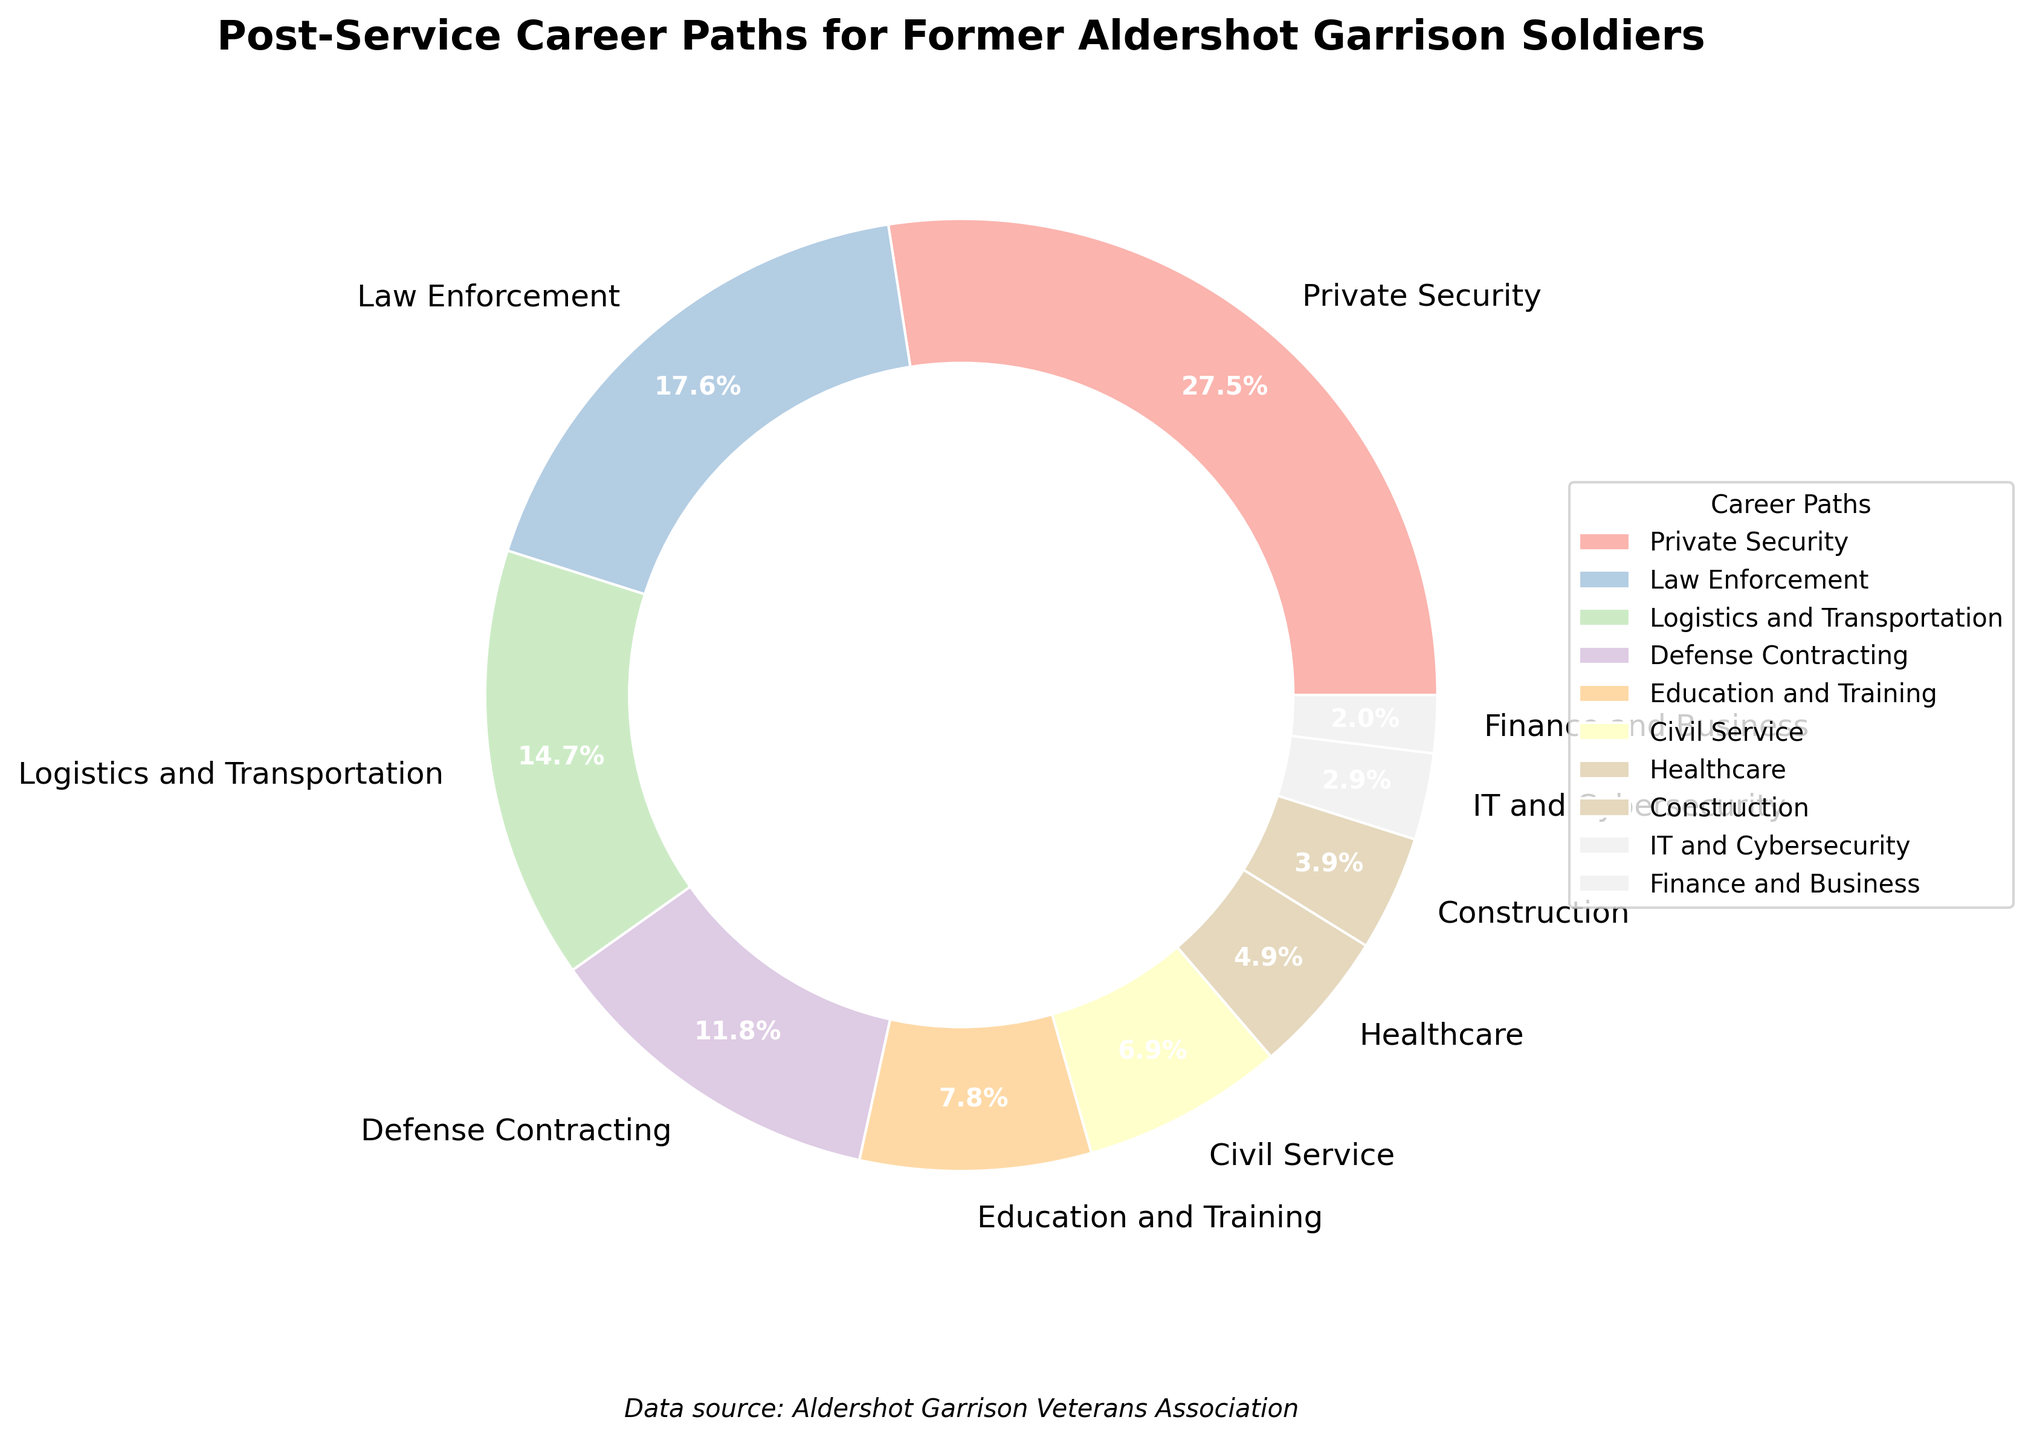What percentage of former Aldershot Garrison soldiers work in Finance and Business? The pie chart shows a sector labeled "Finance and Business" with the percentage clearly indicated.
Answer: 2% What two career paths combined make up exactly 20% of the post-service careers? By adding the percentages of different career paths, the combination of "Education and Training" (8%) and "Civil Service" (7%) equals 15%, adding another path is needed. By adding "Healthcare" (5%), the total becomes 8% + 7% + 5% = 20%.
Answer: Education and Training, Civil Service, and Healthcare Which career path has the highest percentage, and what is it? The largest sector in the pie chart is labeled "Private Security" with the percentage shown.
Answer: Private Security, 28% How much greater is the percentage of former soldiers in Law Enforcement compared to those in Healthcare? The chart shows the Law Enforcement sector at 18% and Healthcare at 5%. The difference is calculated by subtracting the smaller percentage from the larger one.
Answer: 13% What is the visual indication used to differentiate different career paths on the pie chart? The pie chart uses different colors for each sector to differentiate between career paths.
Answer: Different colors What proportion of former soldiers work in sectors related to technology (IT and Cybersecurity)? The pie chart shows the IT and Cybersecurity sector with a percentage indicated.
Answer: 3% What are the combined percentages of soldiers working in Construction, IT and Cybersecurity, and Finance and Business? Adding the percentages from these three career paths: Construction (4%), IT and Cybersecurity (3%), Finance and Business (2%). Sum: 4% + 3% + 2% = 9%.
Answer: 9% Which sector has the smallest representation, and what percentage is it? The smallest sector in the pie chart is labeled "Finance and Business" with the percentage shown.
Answer: Finance and Business, 2% If you combine the percentages of Civil Service and Healthcare, do they surpass Defense Contracting? Civil Service is 7% and Healthcare is 5%. Adding these gives 7% + 5% = 12%, which is equal to the Defense Contracting sector.
Answer: No, they are equal 